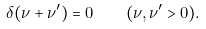<formula> <loc_0><loc_0><loc_500><loc_500>\delta ( \nu + \nu ^ { \prime } ) = 0 \quad ( \nu , \nu ^ { \prime } > 0 ) .</formula> 